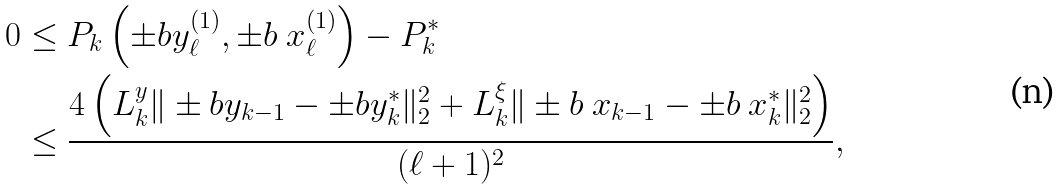<formula> <loc_0><loc_0><loc_500><loc_500>0 & \leq P _ { k } \left ( \pm b { y } ^ { ( 1 ) } _ { \ell } , \pm b { \ x } ^ { ( 1 ) } _ { \ell } \right ) - P _ { k } ^ { * } \\ & \leq \frac { 4 \left ( L _ { k } ^ { y } \| \pm b { y } _ { k - 1 } - \pm b { y } _ { k } ^ { * } \| _ { 2 } ^ { 2 } + L _ { k } ^ { \xi } \| \pm b { \ x } _ { k - 1 } - \pm b { \ x } _ { k } ^ { * } \| _ { 2 } ^ { 2 } \right ) } { ( \ell + 1 ) ^ { 2 } } ,</formula> 